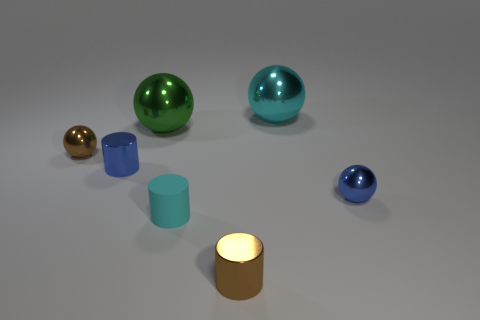Add 2 cyan shiny things. How many objects exist? 9 Subtract all cylinders. How many objects are left? 4 Add 5 shiny cylinders. How many shiny cylinders are left? 7 Add 5 green things. How many green things exist? 6 Subtract 1 brown balls. How many objects are left? 6 Subtract all metallic balls. Subtract all large cyan cubes. How many objects are left? 3 